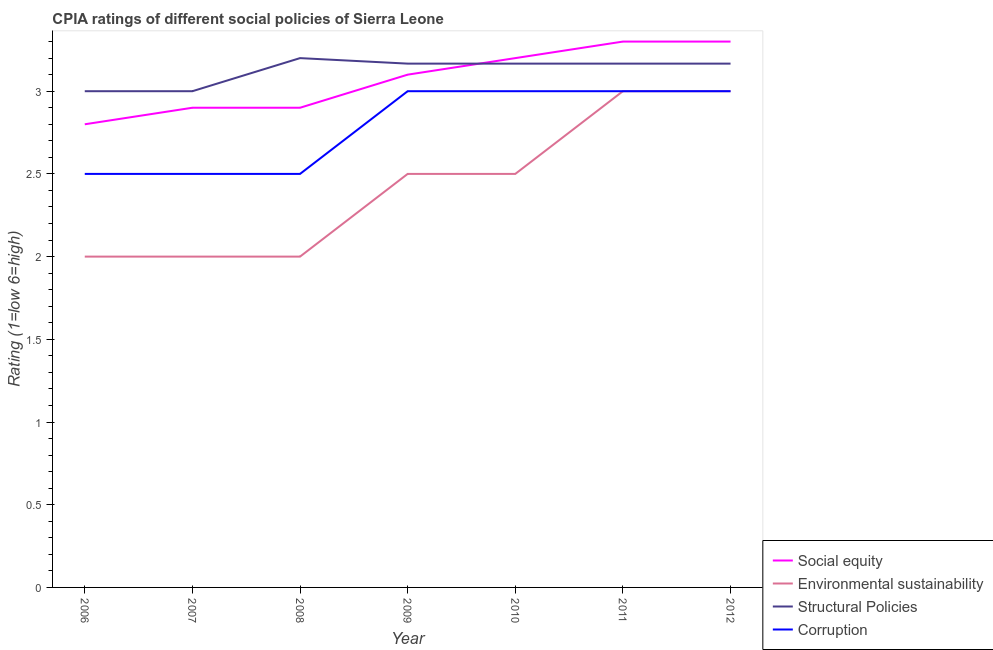Does the line corresponding to cpia rating of social equity intersect with the line corresponding to cpia rating of structural policies?
Ensure brevity in your answer.  Yes. What is the total cpia rating of environmental sustainability in the graph?
Offer a terse response. 17. What is the difference between the cpia rating of social equity in 2007 and that in 2010?
Provide a succinct answer. -0.3. What is the difference between the cpia rating of corruption in 2011 and the cpia rating of environmental sustainability in 2008?
Give a very brief answer. 1. What is the average cpia rating of environmental sustainability per year?
Give a very brief answer. 2.43. In how many years, is the cpia rating of social equity greater than 3.1?
Your answer should be compact. 3. Is the cpia rating of environmental sustainability in 2006 less than that in 2011?
Your response must be concise. Yes. Is the difference between the cpia rating of environmental sustainability in 2006 and 2011 greater than the difference between the cpia rating of structural policies in 2006 and 2011?
Offer a terse response. No. What is the difference between the highest and the second highest cpia rating of environmental sustainability?
Offer a terse response. 0. In how many years, is the cpia rating of social equity greater than the average cpia rating of social equity taken over all years?
Your answer should be compact. 4. Is the sum of the cpia rating of environmental sustainability in 2008 and 2012 greater than the maximum cpia rating of structural policies across all years?
Make the answer very short. Yes. Is it the case that in every year, the sum of the cpia rating of corruption and cpia rating of structural policies is greater than the sum of cpia rating of environmental sustainability and cpia rating of social equity?
Your answer should be very brief. No. Is the cpia rating of social equity strictly greater than the cpia rating of structural policies over the years?
Your answer should be very brief. No. Is the cpia rating of social equity strictly less than the cpia rating of structural policies over the years?
Offer a very short reply. No. How many lines are there?
Provide a succinct answer. 4. How many years are there in the graph?
Provide a short and direct response. 7. Does the graph contain any zero values?
Offer a terse response. No. Does the graph contain grids?
Your answer should be compact. No. How many legend labels are there?
Make the answer very short. 4. What is the title of the graph?
Provide a short and direct response. CPIA ratings of different social policies of Sierra Leone. What is the Rating (1=low 6=high) in Social equity in 2006?
Offer a terse response. 2.8. What is the Rating (1=low 6=high) of Environmental sustainability in 2006?
Keep it short and to the point. 2. What is the Rating (1=low 6=high) of Social equity in 2007?
Your answer should be compact. 2.9. What is the Rating (1=low 6=high) of Environmental sustainability in 2007?
Provide a short and direct response. 2. What is the Rating (1=low 6=high) of Corruption in 2007?
Keep it short and to the point. 2.5. What is the Rating (1=low 6=high) of Environmental sustainability in 2008?
Your answer should be very brief. 2. What is the Rating (1=low 6=high) of Structural Policies in 2008?
Offer a very short reply. 3.2. What is the Rating (1=low 6=high) of Environmental sustainability in 2009?
Provide a short and direct response. 2.5. What is the Rating (1=low 6=high) of Structural Policies in 2009?
Your answer should be compact. 3.17. What is the Rating (1=low 6=high) in Corruption in 2009?
Your answer should be very brief. 3. What is the Rating (1=low 6=high) in Structural Policies in 2010?
Offer a terse response. 3.17. What is the Rating (1=low 6=high) in Corruption in 2010?
Your answer should be very brief. 3. What is the Rating (1=low 6=high) of Social equity in 2011?
Give a very brief answer. 3.3. What is the Rating (1=low 6=high) of Environmental sustainability in 2011?
Give a very brief answer. 3. What is the Rating (1=low 6=high) of Structural Policies in 2011?
Provide a succinct answer. 3.17. What is the Rating (1=low 6=high) of Corruption in 2011?
Your answer should be compact. 3. What is the Rating (1=low 6=high) in Structural Policies in 2012?
Give a very brief answer. 3.17. Across all years, what is the maximum Rating (1=low 6=high) of Environmental sustainability?
Keep it short and to the point. 3. Across all years, what is the maximum Rating (1=low 6=high) of Structural Policies?
Ensure brevity in your answer.  3.2. Across all years, what is the maximum Rating (1=low 6=high) in Corruption?
Provide a succinct answer. 3. Across all years, what is the minimum Rating (1=low 6=high) in Structural Policies?
Provide a succinct answer. 3. Across all years, what is the minimum Rating (1=low 6=high) in Corruption?
Offer a very short reply. 2.5. What is the total Rating (1=low 6=high) in Environmental sustainability in the graph?
Give a very brief answer. 17. What is the total Rating (1=low 6=high) in Structural Policies in the graph?
Give a very brief answer. 21.87. What is the total Rating (1=low 6=high) of Corruption in the graph?
Keep it short and to the point. 19.5. What is the difference between the Rating (1=low 6=high) of Social equity in 2006 and that in 2007?
Offer a very short reply. -0.1. What is the difference between the Rating (1=low 6=high) in Corruption in 2006 and that in 2007?
Your answer should be compact. 0. What is the difference between the Rating (1=low 6=high) of Social equity in 2006 and that in 2008?
Keep it short and to the point. -0.1. What is the difference between the Rating (1=low 6=high) of Environmental sustainability in 2006 and that in 2008?
Provide a succinct answer. 0. What is the difference between the Rating (1=low 6=high) of Corruption in 2006 and that in 2008?
Your response must be concise. 0. What is the difference between the Rating (1=low 6=high) in Social equity in 2006 and that in 2009?
Provide a short and direct response. -0.3. What is the difference between the Rating (1=low 6=high) in Environmental sustainability in 2006 and that in 2009?
Ensure brevity in your answer.  -0.5. What is the difference between the Rating (1=low 6=high) in Structural Policies in 2006 and that in 2009?
Offer a terse response. -0.17. What is the difference between the Rating (1=low 6=high) in Structural Policies in 2006 and that in 2010?
Keep it short and to the point. -0.17. What is the difference between the Rating (1=low 6=high) in Environmental sustainability in 2006 and that in 2011?
Give a very brief answer. -1. What is the difference between the Rating (1=low 6=high) in Corruption in 2006 and that in 2011?
Ensure brevity in your answer.  -0.5. What is the difference between the Rating (1=low 6=high) in Social equity in 2006 and that in 2012?
Offer a terse response. -0.5. What is the difference between the Rating (1=low 6=high) of Social equity in 2007 and that in 2008?
Ensure brevity in your answer.  0. What is the difference between the Rating (1=low 6=high) in Structural Policies in 2007 and that in 2008?
Offer a terse response. -0.2. What is the difference between the Rating (1=low 6=high) in Corruption in 2007 and that in 2008?
Provide a short and direct response. 0. What is the difference between the Rating (1=low 6=high) of Social equity in 2007 and that in 2009?
Make the answer very short. -0.2. What is the difference between the Rating (1=low 6=high) of Environmental sustainability in 2007 and that in 2009?
Your response must be concise. -0.5. What is the difference between the Rating (1=low 6=high) of Structural Policies in 2007 and that in 2009?
Provide a short and direct response. -0.17. What is the difference between the Rating (1=low 6=high) of Corruption in 2007 and that in 2009?
Your response must be concise. -0.5. What is the difference between the Rating (1=low 6=high) in Environmental sustainability in 2007 and that in 2010?
Your answer should be compact. -0.5. What is the difference between the Rating (1=low 6=high) of Social equity in 2007 and that in 2011?
Ensure brevity in your answer.  -0.4. What is the difference between the Rating (1=low 6=high) of Corruption in 2007 and that in 2011?
Keep it short and to the point. -0.5. What is the difference between the Rating (1=low 6=high) of Social equity in 2007 and that in 2012?
Keep it short and to the point. -0.4. What is the difference between the Rating (1=low 6=high) in Structural Policies in 2007 and that in 2012?
Provide a short and direct response. -0.17. What is the difference between the Rating (1=low 6=high) in Corruption in 2008 and that in 2009?
Your answer should be very brief. -0.5. What is the difference between the Rating (1=low 6=high) of Environmental sustainability in 2008 and that in 2010?
Provide a succinct answer. -0.5. What is the difference between the Rating (1=low 6=high) of Structural Policies in 2008 and that in 2010?
Your response must be concise. 0.03. What is the difference between the Rating (1=low 6=high) in Corruption in 2008 and that in 2010?
Offer a terse response. -0.5. What is the difference between the Rating (1=low 6=high) in Environmental sustainability in 2008 and that in 2011?
Offer a terse response. -1. What is the difference between the Rating (1=low 6=high) of Corruption in 2008 and that in 2011?
Provide a short and direct response. -0.5. What is the difference between the Rating (1=low 6=high) in Environmental sustainability in 2008 and that in 2012?
Provide a short and direct response. -1. What is the difference between the Rating (1=low 6=high) of Corruption in 2008 and that in 2012?
Your response must be concise. -0.5. What is the difference between the Rating (1=low 6=high) of Environmental sustainability in 2009 and that in 2010?
Offer a very short reply. 0. What is the difference between the Rating (1=low 6=high) of Environmental sustainability in 2009 and that in 2011?
Make the answer very short. -0.5. What is the difference between the Rating (1=low 6=high) in Structural Policies in 2009 and that in 2011?
Provide a succinct answer. 0. What is the difference between the Rating (1=low 6=high) of Corruption in 2009 and that in 2011?
Your answer should be compact. 0. What is the difference between the Rating (1=low 6=high) in Social equity in 2009 and that in 2012?
Provide a short and direct response. -0.2. What is the difference between the Rating (1=low 6=high) of Social equity in 2010 and that in 2011?
Provide a short and direct response. -0.1. What is the difference between the Rating (1=low 6=high) in Structural Policies in 2010 and that in 2011?
Make the answer very short. 0. What is the difference between the Rating (1=low 6=high) of Corruption in 2010 and that in 2011?
Your answer should be compact. 0. What is the difference between the Rating (1=low 6=high) of Social equity in 2010 and that in 2012?
Give a very brief answer. -0.1. What is the difference between the Rating (1=low 6=high) of Structural Policies in 2010 and that in 2012?
Your answer should be very brief. 0. What is the difference between the Rating (1=low 6=high) of Social equity in 2011 and that in 2012?
Keep it short and to the point. 0. What is the difference between the Rating (1=low 6=high) in Corruption in 2011 and that in 2012?
Your answer should be very brief. 0. What is the difference between the Rating (1=low 6=high) in Social equity in 2006 and the Rating (1=low 6=high) in Structural Policies in 2007?
Keep it short and to the point. -0.2. What is the difference between the Rating (1=low 6=high) of Environmental sustainability in 2006 and the Rating (1=low 6=high) of Corruption in 2007?
Your answer should be very brief. -0.5. What is the difference between the Rating (1=low 6=high) of Structural Policies in 2006 and the Rating (1=low 6=high) of Corruption in 2007?
Make the answer very short. 0.5. What is the difference between the Rating (1=low 6=high) of Social equity in 2006 and the Rating (1=low 6=high) of Structural Policies in 2008?
Give a very brief answer. -0.4. What is the difference between the Rating (1=low 6=high) of Social equity in 2006 and the Rating (1=low 6=high) of Corruption in 2008?
Your answer should be compact. 0.3. What is the difference between the Rating (1=low 6=high) of Structural Policies in 2006 and the Rating (1=low 6=high) of Corruption in 2008?
Your answer should be very brief. 0.5. What is the difference between the Rating (1=low 6=high) in Social equity in 2006 and the Rating (1=low 6=high) in Environmental sustainability in 2009?
Your answer should be compact. 0.3. What is the difference between the Rating (1=low 6=high) of Social equity in 2006 and the Rating (1=low 6=high) of Structural Policies in 2009?
Provide a short and direct response. -0.37. What is the difference between the Rating (1=low 6=high) of Environmental sustainability in 2006 and the Rating (1=low 6=high) of Structural Policies in 2009?
Provide a short and direct response. -1.17. What is the difference between the Rating (1=low 6=high) of Environmental sustainability in 2006 and the Rating (1=low 6=high) of Corruption in 2009?
Keep it short and to the point. -1. What is the difference between the Rating (1=low 6=high) in Structural Policies in 2006 and the Rating (1=low 6=high) in Corruption in 2009?
Your answer should be compact. 0. What is the difference between the Rating (1=low 6=high) in Social equity in 2006 and the Rating (1=low 6=high) in Structural Policies in 2010?
Offer a terse response. -0.37. What is the difference between the Rating (1=low 6=high) in Social equity in 2006 and the Rating (1=low 6=high) in Corruption in 2010?
Provide a succinct answer. -0.2. What is the difference between the Rating (1=low 6=high) of Environmental sustainability in 2006 and the Rating (1=low 6=high) of Structural Policies in 2010?
Your response must be concise. -1.17. What is the difference between the Rating (1=low 6=high) in Environmental sustainability in 2006 and the Rating (1=low 6=high) in Corruption in 2010?
Provide a short and direct response. -1. What is the difference between the Rating (1=low 6=high) in Social equity in 2006 and the Rating (1=low 6=high) in Environmental sustainability in 2011?
Keep it short and to the point. -0.2. What is the difference between the Rating (1=low 6=high) in Social equity in 2006 and the Rating (1=low 6=high) in Structural Policies in 2011?
Keep it short and to the point. -0.37. What is the difference between the Rating (1=low 6=high) of Social equity in 2006 and the Rating (1=low 6=high) of Corruption in 2011?
Ensure brevity in your answer.  -0.2. What is the difference between the Rating (1=low 6=high) in Environmental sustainability in 2006 and the Rating (1=low 6=high) in Structural Policies in 2011?
Your answer should be very brief. -1.17. What is the difference between the Rating (1=low 6=high) of Environmental sustainability in 2006 and the Rating (1=low 6=high) of Corruption in 2011?
Offer a very short reply. -1. What is the difference between the Rating (1=low 6=high) of Social equity in 2006 and the Rating (1=low 6=high) of Structural Policies in 2012?
Give a very brief answer. -0.37. What is the difference between the Rating (1=low 6=high) of Social equity in 2006 and the Rating (1=low 6=high) of Corruption in 2012?
Provide a short and direct response. -0.2. What is the difference between the Rating (1=low 6=high) in Environmental sustainability in 2006 and the Rating (1=low 6=high) in Structural Policies in 2012?
Ensure brevity in your answer.  -1.17. What is the difference between the Rating (1=low 6=high) of Environmental sustainability in 2006 and the Rating (1=low 6=high) of Corruption in 2012?
Offer a terse response. -1. What is the difference between the Rating (1=low 6=high) in Social equity in 2007 and the Rating (1=low 6=high) in Structural Policies in 2008?
Keep it short and to the point. -0.3. What is the difference between the Rating (1=low 6=high) of Environmental sustainability in 2007 and the Rating (1=low 6=high) of Corruption in 2008?
Provide a short and direct response. -0.5. What is the difference between the Rating (1=low 6=high) of Structural Policies in 2007 and the Rating (1=low 6=high) of Corruption in 2008?
Your answer should be very brief. 0.5. What is the difference between the Rating (1=low 6=high) in Social equity in 2007 and the Rating (1=low 6=high) in Environmental sustainability in 2009?
Keep it short and to the point. 0.4. What is the difference between the Rating (1=low 6=high) in Social equity in 2007 and the Rating (1=low 6=high) in Structural Policies in 2009?
Your answer should be very brief. -0.27. What is the difference between the Rating (1=low 6=high) of Environmental sustainability in 2007 and the Rating (1=low 6=high) of Structural Policies in 2009?
Provide a succinct answer. -1.17. What is the difference between the Rating (1=low 6=high) of Environmental sustainability in 2007 and the Rating (1=low 6=high) of Corruption in 2009?
Give a very brief answer. -1. What is the difference between the Rating (1=low 6=high) in Structural Policies in 2007 and the Rating (1=low 6=high) in Corruption in 2009?
Your response must be concise. 0. What is the difference between the Rating (1=low 6=high) of Social equity in 2007 and the Rating (1=low 6=high) of Structural Policies in 2010?
Your answer should be compact. -0.27. What is the difference between the Rating (1=low 6=high) of Social equity in 2007 and the Rating (1=low 6=high) of Corruption in 2010?
Make the answer very short. -0.1. What is the difference between the Rating (1=low 6=high) in Environmental sustainability in 2007 and the Rating (1=low 6=high) in Structural Policies in 2010?
Keep it short and to the point. -1.17. What is the difference between the Rating (1=low 6=high) of Structural Policies in 2007 and the Rating (1=low 6=high) of Corruption in 2010?
Keep it short and to the point. 0. What is the difference between the Rating (1=low 6=high) in Social equity in 2007 and the Rating (1=low 6=high) in Environmental sustainability in 2011?
Give a very brief answer. -0.1. What is the difference between the Rating (1=low 6=high) in Social equity in 2007 and the Rating (1=low 6=high) in Structural Policies in 2011?
Offer a very short reply. -0.27. What is the difference between the Rating (1=low 6=high) in Social equity in 2007 and the Rating (1=low 6=high) in Corruption in 2011?
Provide a succinct answer. -0.1. What is the difference between the Rating (1=low 6=high) of Environmental sustainability in 2007 and the Rating (1=low 6=high) of Structural Policies in 2011?
Keep it short and to the point. -1.17. What is the difference between the Rating (1=low 6=high) in Environmental sustainability in 2007 and the Rating (1=low 6=high) in Corruption in 2011?
Offer a very short reply. -1. What is the difference between the Rating (1=low 6=high) in Structural Policies in 2007 and the Rating (1=low 6=high) in Corruption in 2011?
Your answer should be compact. 0. What is the difference between the Rating (1=low 6=high) of Social equity in 2007 and the Rating (1=low 6=high) of Structural Policies in 2012?
Keep it short and to the point. -0.27. What is the difference between the Rating (1=low 6=high) of Social equity in 2007 and the Rating (1=low 6=high) of Corruption in 2012?
Provide a succinct answer. -0.1. What is the difference between the Rating (1=low 6=high) of Environmental sustainability in 2007 and the Rating (1=low 6=high) of Structural Policies in 2012?
Offer a very short reply. -1.17. What is the difference between the Rating (1=low 6=high) of Social equity in 2008 and the Rating (1=low 6=high) of Environmental sustainability in 2009?
Your answer should be very brief. 0.4. What is the difference between the Rating (1=low 6=high) in Social equity in 2008 and the Rating (1=low 6=high) in Structural Policies in 2009?
Keep it short and to the point. -0.27. What is the difference between the Rating (1=low 6=high) of Social equity in 2008 and the Rating (1=low 6=high) of Corruption in 2009?
Provide a short and direct response. -0.1. What is the difference between the Rating (1=low 6=high) of Environmental sustainability in 2008 and the Rating (1=low 6=high) of Structural Policies in 2009?
Keep it short and to the point. -1.17. What is the difference between the Rating (1=low 6=high) of Environmental sustainability in 2008 and the Rating (1=low 6=high) of Corruption in 2009?
Your response must be concise. -1. What is the difference between the Rating (1=low 6=high) in Social equity in 2008 and the Rating (1=low 6=high) in Environmental sustainability in 2010?
Your answer should be compact. 0.4. What is the difference between the Rating (1=low 6=high) of Social equity in 2008 and the Rating (1=low 6=high) of Structural Policies in 2010?
Provide a succinct answer. -0.27. What is the difference between the Rating (1=low 6=high) of Environmental sustainability in 2008 and the Rating (1=low 6=high) of Structural Policies in 2010?
Ensure brevity in your answer.  -1.17. What is the difference between the Rating (1=low 6=high) of Environmental sustainability in 2008 and the Rating (1=low 6=high) of Corruption in 2010?
Your answer should be compact. -1. What is the difference between the Rating (1=low 6=high) of Structural Policies in 2008 and the Rating (1=low 6=high) of Corruption in 2010?
Your answer should be compact. 0.2. What is the difference between the Rating (1=low 6=high) in Social equity in 2008 and the Rating (1=low 6=high) in Structural Policies in 2011?
Ensure brevity in your answer.  -0.27. What is the difference between the Rating (1=low 6=high) in Social equity in 2008 and the Rating (1=low 6=high) in Corruption in 2011?
Offer a very short reply. -0.1. What is the difference between the Rating (1=low 6=high) in Environmental sustainability in 2008 and the Rating (1=low 6=high) in Structural Policies in 2011?
Your answer should be compact. -1.17. What is the difference between the Rating (1=low 6=high) of Social equity in 2008 and the Rating (1=low 6=high) of Environmental sustainability in 2012?
Give a very brief answer. -0.1. What is the difference between the Rating (1=low 6=high) of Social equity in 2008 and the Rating (1=low 6=high) of Structural Policies in 2012?
Offer a terse response. -0.27. What is the difference between the Rating (1=low 6=high) in Social equity in 2008 and the Rating (1=low 6=high) in Corruption in 2012?
Your answer should be compact. -0.1. What is the difference between the Rating (1=low 6=high) of Environmental sustainability in 2008 and the Rating (1=low 6=high) of Structural Policies in 2012?
Offer a very short reply. -1.17. What is the difference between the Rating (1=low 6=high) of Social equity in 2009 and the Rating (1=low 6=high) of Environmental sustainability in 2010?
Provide a succinct answer. 0.6. What is the difference between the Rating (1=low 6=high) of Social equity in 2009 and the Rating (1=low 6=high) of Structural Policies in 2010?
Your response must be concise. -0.07. What is the difference between the Rating (1=low 6=high) in Social equity in 2009 and the Rating (1=low 6=high) in Structural Policies in 2011?
Make the answer very short. -0.07. What is the difference between the Rating (1=low 6=high) in Social equity in 2009 and the Rating (1=low 6=high) in Corruption in 2011?
Offer a terse response. 0.1. What is the difference between the Rating (1=low 6=high) of Environmental sustainability in 2009 and the Rating (1=low 6=high) of Structural Policies in 2011?
Your answer should be very brief. -0.67. What is the difference between the Rating (1=low 6=high) of Social equity in 2009 and the Rating (1=low 6=high) of Structural Policies in 2012?
Ensure brevity in your answer.  -0.07. What is the difference between the Rating (1=low 6=high) of Social equity in 2010 and the Rating (1=low 6=high) of Corruption in 2011?
Your response must be concise. 0.2. What is the difference between the Rating (1=low 6=high) of Environmental sustainability in 2010 and the Rating (1=low 6=high) of Structural Policies in 2011?
Make the answer very short. -0.67. What is the difference between the Rating (1=low 6=high) in Social equity in 2010 and the Rating (1=low 6=high) in Environmental sustainability in 2012?
Offer a very short reply. 0.2. What is the difference between the Rating (1=low 6=high) of Social equity in 2011 and the Rating (1=low 6=high) of Structural Policies in 2012?
Make the answer very short. 0.13. What is the difference between the Rating (1=low 6=high) of Social equity in 2011 and the Rating (1=low 6=high) of Corruption in 2012?
Give a very brief answer. 0.3. What is the difference between the Rating (1=low 6=high) in Environmental sustainability in 2011 and the Rating (1=low 6=high) in Structural Policies in 2012?
Offer a terse response. -0.17. What is the difference between the Rating (1=low 6=high) in Structural Policies in 2011 and the Rating (1=low 6=high) in Corruption in 2012?
Offer a very short reply. 0.17. What is the average Rating (1=low 6=high) in Social equity per year?
Offer a terse response. 3.07. What is the average Rating (1=low 6=high) of Environmental sustainability per year?
Keep it short and to the point. 2.43. What is the average Rating (1=low 6=high) in Structural Policies per year?
Provide a short and direct response. 3.12. What is the average Rating (1=low 6=high) of Corruption per year?
Offer a terse response. 2.79. In the year 2006, what is the difference between the Rating (1=low 6=high) of Social equity and Rating (1=low 6=high) of Environmental sustainability?
Offer a very short reply. 0.8. In the year 2006, what is the difference between the Rating (1=low 6=high) of Environmental sustainability and Rating (1=low 6=high) of Structural Policies?
Your response must be concise. -1. In the year 2006, what is the difference between the Rating (1=low 6=high) of Structural Policies and Rating (1=low 6=high) of Corruption?
Provide a short and direct response. 0.5. In the year 2007, what is the difference between the Rating (1=low 6=high) of Social equity and Rating (1=low 6=high) of Environmental sustainability?
Keep it short and to the point. 0.9. In the year 2007, what is the difference between the Rating (1=low 6=high) in Social equity and Rating (1=low 6=high) in Structural Policies?
Give a very brief answer. -0.1. In the year 2007, what is the difference between the Rating (1=low 6=high) of Social equity and Rating (1=low 6=high) of Corruption?
Provide a succinct answer. 0.4. In the year 2008, what is the difference between the Rating (1=low 6=high) of Social equity and Rating (1=low 6=high) of Environmental sustainability?
Offer a very short reply. 0.9. In the year 2008, what is the difference between the Rating (1=low 6=high) in Social equity and Rating (1=low 6=high) in Structural Policies?
Offer a very short reply. -0.3. In the year 2008, what is the difference between the Rating (1=low 6=high) in Social equity and Rating (1=low 6=high) in Corruption?
Keep it short and to the point. 0.4. In the year 2008, what is the difference between the Rating (1=low 6=high) in Environmental sustainability and Rating (1=low 6=high) in Structural Policies?
Provide a short and direct response. -1.2. In the year 2008, what is the difference between the Rating (1=low 6=high) of Structural Policies and Rating (1=low 6=high) of Corruption?
Offer a terse response. 0.7. In the year 2009, what is the difference between the Rating (1=low 6=high) in Social equity and Rating (1=low 6=high) in Environmental sustainability?
Offer a terse response. 0.6. In the year 2009, what is the difference between the Rating (1=low 6=high) of Social equity and Rating (1=low 6=high) of Structural Policies?
Give a very brief answer. -0.07. In the year 2009, what is the difference between the Rating (1=low 6=high) of Environmental sustainability and Rating (1=low 6=high) of Structural Policies?
Offer a terse response. -0.67. In the year 2009, what is the difference between the Rating (1=low 6=high) of Environmental sustainability and Rating (1=low 6=high) of Corruption?
Provide a succinct answer. -0.5. In the year 2009, what is the difference between the Rating (1=low 6=high) in Structural Policies and Rating (1=low 6=high) in Corruption?
Provide a short and direct response. 0.17. In the year 2010, what is the difference between the Rating (1=low 6=high) in Social equity and Rating (1=low 6=high) in Corruption?
Keep it short and to the point. 0.2. In the year 2010, what is the difference between the Rating (1=low 6=high) of Environmental sustainability and Rating (1=low 6=high) of Structural Policies?
Offer a terse response. -0.67. In the year 2011, what is the difference between the Rating (1=low 6=high) of Social equity and Rating (1=low 6=high) of Structural Policies?
Provide a short and direct response. 0.13. In the year 2011, what is the difference between the Rating (1=low 6=high) in Environmental sustainability and Rating (1=low 6=high) in Structural Policies?
Make the answer very short. -0.17. In the year 2012, what is the difference between the Rating (1=low 6=high) of Social equity and Rating (1=low 6=high) of Structural Policies?
Your response must be concise. 0.13. In the year 2012, what is the difference between the Rating (1=low 6=high) of Environmental sustainability and Rating (1=low 6=high) of Corruption?
Offer a terse response. 0. In the year 2012, what is the difference between the Rating (1=low 6=high) in Structural Policies and Rating (1=low 6=high) in Corruption?
Make the answer very short. 0.17. What is the ratio of the Rating (1=low 6=high) in Social equity in 2006 to that in 2007?
Your answer should be compact. 0.97. What is the ratio of the Rating (1=low 6=high) in Environmental sustainability in 2006 to that in 2007?
Offer a terse response. 1. What is the ratio of the Rating (1=low 6=high) of Corruption in 2006 to that in 2007?
Your answer should be compact. 1. What is the ratio of the Rating (1=low 6=high) of Social equity in 2006 to that in 2008?
Your answer should be compact. 0.97. What is the ratio of the Rating (1=low 6=high) in Environmental sustainability in 2006 to that in 2008?
Offer a very short reply. 1. What is the ratio of the Rating (1=low 6=high) in Structural Policies in 2006 to that in 2008?
Provide a succinct answer. 0.94. What is the ratio of the Rating (1=low 6=high) of Corruption in 2006 to that in 2008?
Your answer should be very brief. 1. What is the ratio of the Rating (1=low 6=high) of Social equity in 2006 to that in 2009?
Provide a succinct answer. 0.9. What is the ratio of the Rating (1=low 6=high) of Environmental sustainability in 2006 to that in 2009?
Your answer should be very brief. 0.8. What is the ratio of the Rating (1=low 6=high) in Structural Policies in 2006 to that in 2009?
Provide a short and direct response. 0.95. What is the ratio of the Rating (1=low 6=high) of Social equity in 2006 to that in 2010?
Provide a short and direct response. 0.88. What is the ratio of the Rating (1=low 6=high) in Environmental sustainability in 2006 to that in 2010?
Your answer should be very brief. 0.8. What is the ratio of the Rating (1=low 6=high) in Corruption in 2006 to that in 2010?
Keep it short and to the point. 0.83. What is the ratio of the Rating (1=low 6=high) of Social equity in 2006 to that in 2011?
Make the answer very short. 0.85. What is the ratio of the Rating (1=low 6=high) of Structural Policies in 2006 to that in 2011?
Provide a succinct answer. 0.95. What is the ratio of the Rating (1=low 6=high) of Social equity in 2006 to that in 2012?
Provide a short and direct response. 0.85. What is the ratio of the Rating (1=low 6=high) in Environmental sustainability in 2006 to that in 2012?
Ensure brevity in your answer.  0.67. What is the ratio of the Rating (1=low 6=high) in Structural Policies in 2006 to that in 2012?
Make the answer very short. 0.95. What is the ratio of the Rating (1=low 6=high) of Corruption in 2006 to that in 2012?
Give a very brief answer. 0.83. What is the ratio of the Rating (1=low 6=high) of Structural Policies in 2007 to that in 2008?
Your answer should be very brief. 0.94. What is the ratio of the Rating (1=low 6=high) of Social equity in 2007 to that in 2009?
Keep it short and to the point. 0.94. What is the ratio of the Rating (1=low 6=high) of Structural Policies in 2007 to that in 2009?
Provide a succinct answer. 0.95. What is the ratio of the Rating (1=low 6=high) in Social equity in 2007 to that in 2010?
Your response must be concise. 0.91. What is the ratio of the Rating (1=low 6=high) in Corruption in 2007 to that in 2010?
Offer a terse response. 0.83. What is the ratio of the Rating (1=low 6=high) in Social equity in 2007 to that in 2011?
Provide a succinct answer. 0.88. What is the ratio of the Rating (1=low 6=high) of Environmental sustainability in 2007 to that in 2011?
Keep it short and to the point. 0.67. What is the ratio of the Rating (1=low 6=high) in Social equity in 2007 to that in 2012?
Provide a succinct answer. 0.88. What is the ratio of the Rating (1=low 6=high) of Structural Policies in 2007 to that in 2012?
Provide a succinct answer. 0.95. What is the ratio of the Rating (1=low 6=high) in Social equity in 2008 to that in 2009?
Your answer should be compact. 0.94. What is the ratio of the Rating (1=low 6=high) of Structural Policies in 2008 to that in 2009?
Give a very brief answer. 1.01. What is the ratio of the Rating (1=low 6=high) of Social equity in 2008 to that in 2010?
Offer a very short reply. 0.91. What is the ratio of the Rating (1=low 6=high) of Structural Policies in 2008 to that in 2010?
Your response must be concise. 1.01. What is the ratio of the Rating (1=low 6=high) of Corruption in 2008 to that in 2010?
Provide a succinct answer. 0.83. What is the ratio of the Rating (1=low 6=high) in Social equity in 2008 to that in 2011?
Make the answer very short. 0.88. What is the ratio of the Rating (1=low 6=high) of Structural Policies in 2008 to that in 2011?
Make the answer very short. 1.01. What is the ratio of the Rating (1=low 6=high) of Social equity in 2008 to that in 2012?
Offer a terse response. 0.88. What is the ratio of the Rating (1=low 6=high) of Structural Policies in 2008 to that in 2012?
Your answer should be compact. 1.01. What is the ratio of the Rating (1=low 6=high) in Corruption in 2008 to that in 2012?
Your answer should be compact. 0.83. What is the ratio of the Rating (1=low 6=high) in Social equity in 2009 to that in 2010?
Offer a terse response. 0.97. What is the ratio of the Rating (1=low 6=high) in Corruption in 2009 to that in 2010?
Offer a very short reply. 1. What is the ratio of the Rating (1=low 6=high) of Social equity in 2009 to that in 2011?
Offer a terse response. 0.94. What is the ratio of the Rating (1=low 6=high) in Environmental sustainability in 2009 to that in 2011?
Offer a terse response. 0.83. What is the ratio of the Rating (1=low 6=high) in Structural Policies in 2009 to that in 2011?
Offer a very short reply. 1. What is the ratio of the Rating (1=low 6=high) in Social equity in 2009 to that in 2012?
Make the answer very short. 0.94. What is the ratio of the Rating (1=low 6=high) in Structural Policies in 2009 to that in 2012?
Offer a terse response. 1. What is the ratio of the Rating (1=low 6=high) of Corruption in 2009 to that in 2012?
Give a very brief answer. 1. What is the ratio of the Rating (1=low 6=high) of Social equity in 2010 to that in 2011?
Provide a short and direct response. 0.97. What is the ratio of the Rating (1=low 6=high) of Social equity in 2010 to that in 2012?
Offer a very short reply. 0.97. What is the ratio of the Rating (1=low 6=high) in Structural Policies in 2010 to that in 2012?
Give a very brief answer. 1. What is the ratio of the Rating (1=low 6=high) of Social equity in 2011 to that in 2012?
Make the answer very short. 1. What is the ratio of the Rating (1=low 6=high) in Structural Policies in 2011 to that in 2012?
Give a very brief answer. 1. What is the difference between the highest and the lowest Rating (1=low 6=high) in Social equity?
Provide a short and direct response. 0.5. What is the difference between the highest and the lowest Rating (1=low 6=high) in Environmental sustainability?
Make the answer very short. 1. What is the difference between the highest and the lowest Rating (1=low 6=high) in Structural Policies?
Your answer should be very brief. 0.2. What is the difference between the highest and the lowest Rating (1=low 6=high) of Corruption?
Make the answer very short. 0.5. 